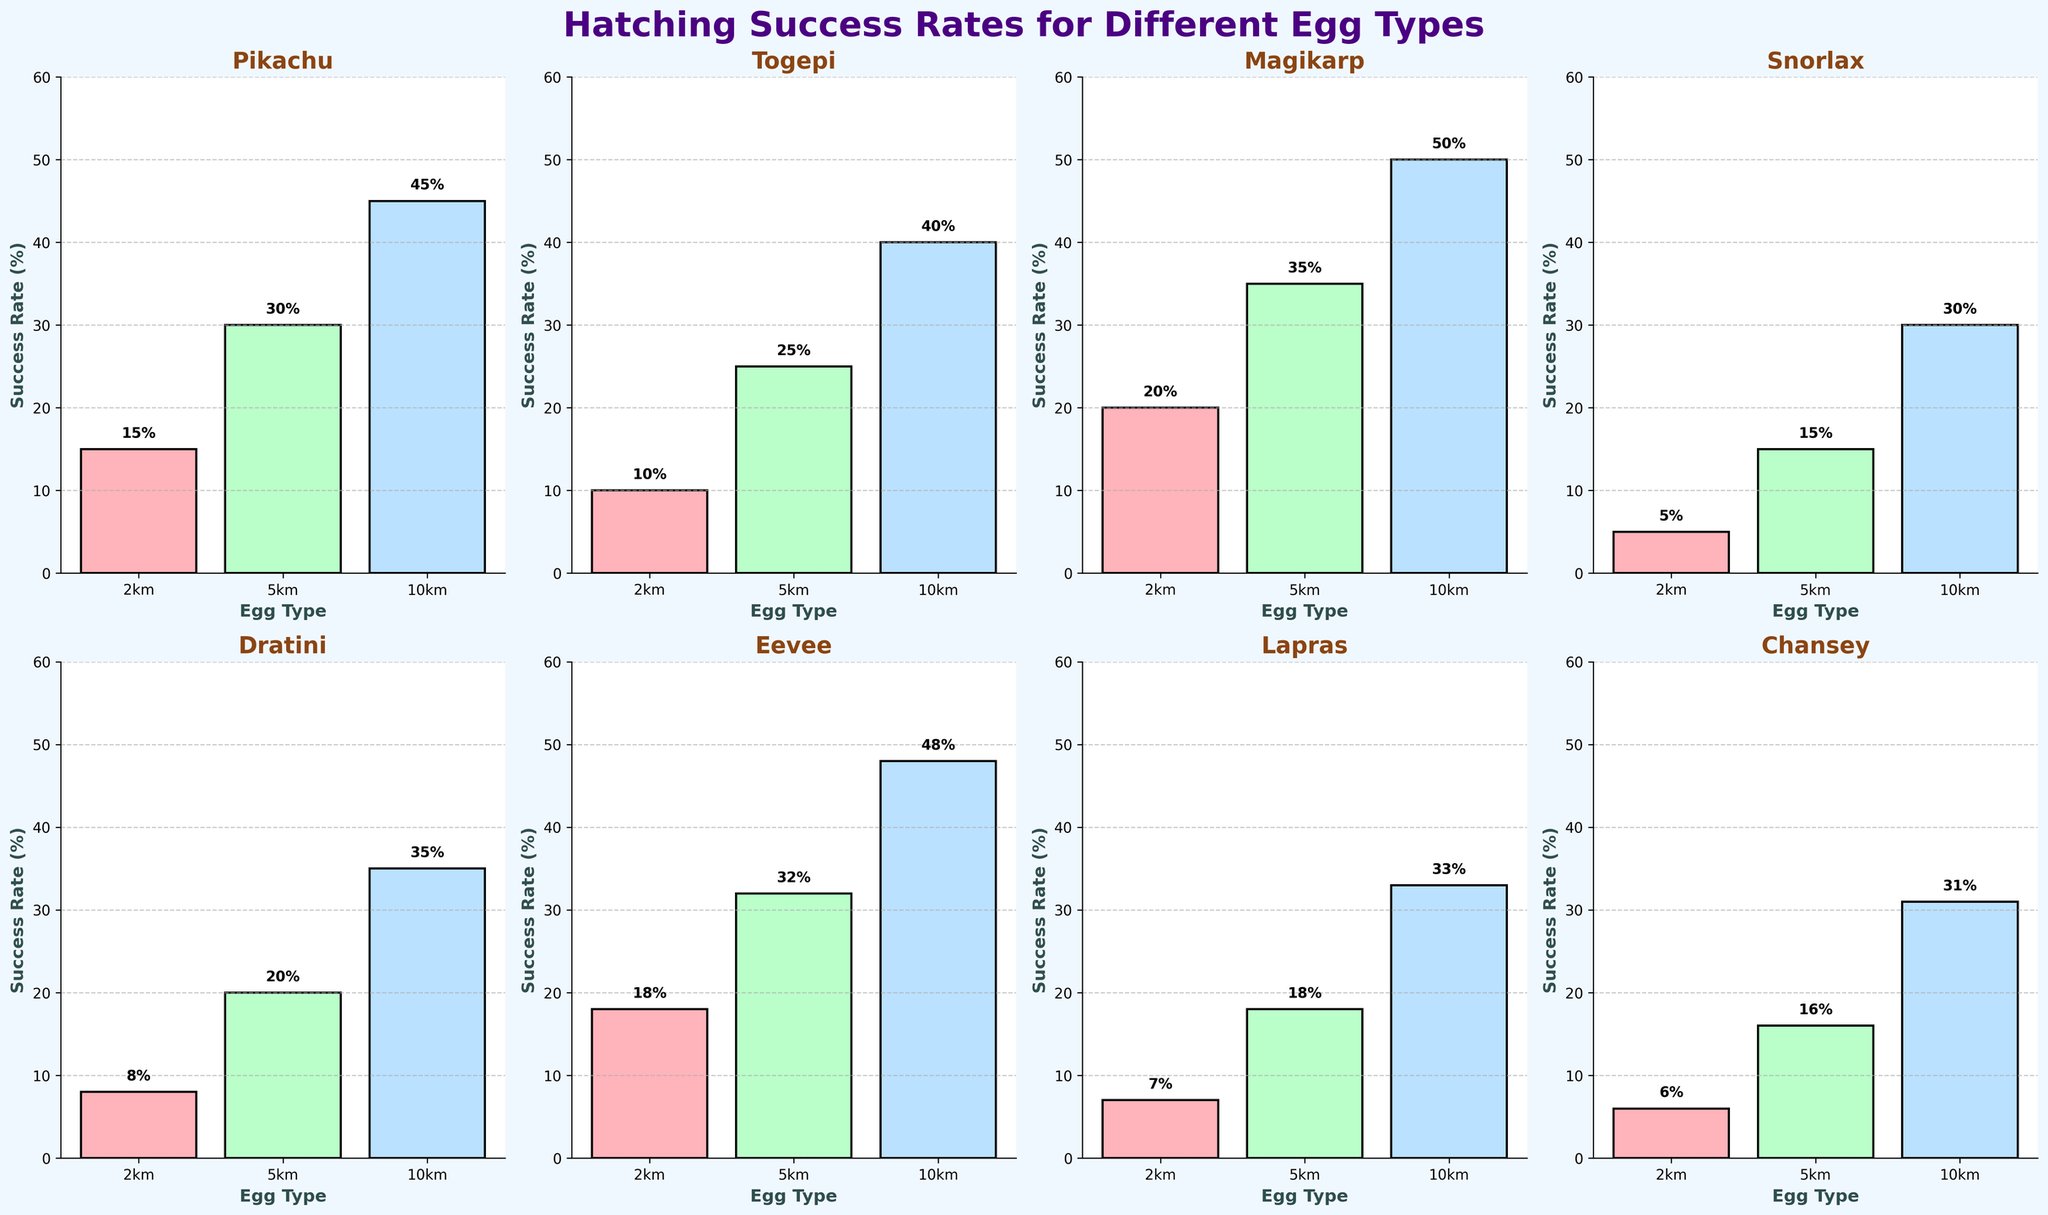What is the hatching success rate for Pikachu from a 2km egg? Look at the subplot for Pikachu and refer to the bar labeled '2km'. The height of the bar indicates the success rate in percentage, which is also labeled above the bar.
Answer: 15% Which Pokémon has the lowest hatching success rate from a 10km egg? Compare the heights of the bars labeled '10km' in each subplot. Identify the Pokémon with the bar of the smallest height, which is also labeled on the bar.
Answer: Snorlax What’s the difference in success rate between hatching Lapras from a 2km egg and an Eevee from a 5km egg? Identify the success rate for Lapras from a 2km egg and Eevee from a 5km egg by looking at the respective subplots and their bars. Calculate the difference between these rates. Lapras (2km) = 7%, Eevee (5km) = 32%, thus 32% - 7% = 25%.
Answer: 25% Which egg type generally has the highest success rate across all Pokémon? Observe the tallest bars across all subplots for each egg type (2km, 5km, 10km). Identify which egg type consistently shows the highest values in the majority of subplots. The '10km' egg type usually has the tallest bars.
Answer: 10km What is the average success rate of Chansey from all egg types? Identify the success rates from the subplot for Chansey: 6% (2km), 16% (5km), 31% (10km). Calculate the average by summing these percentages and dividing by the number of egg types. (6% + 16% + 31%) / 3 = 17.67%.
Answer: 17.67% Which Pokémon has the highest success rate from a 5km egg? Compare the heights of the bars labeled '5km' in each subplot. Identify the Pokémon with the tallest bar, which is also labeled on the bar.
Answer: Magikarp Among the listed Pokémon, which one has the most balanced success rate across all egg types? Observe each Pokémon's subplot to check how close their success rates are across 2km, 5km, and 10km eggs. Eevee has rates at 18%, 32%, and 48%, which are relatively spread out. Pikachu, with rates at 15%, 30%, and 45%, shows the smallest spread between its values.
Answer: Pikachu What’s the total success rate for hatching Togepi from all egg types? Identify the success rates from the subplot for Togepi: 10% (2km), 25% (5km), 40% (10km). Sum these percentages to get the total. 10% + 25% + 40% = 75%.
Answer: 75% 